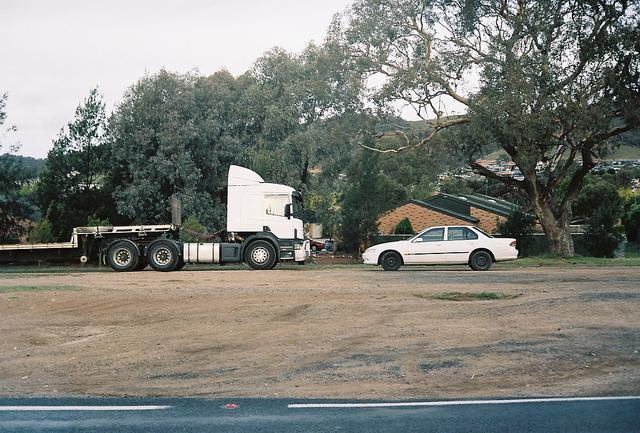What is this type of truck called?

Choices:
A) dump truck
B) cement truck
C) semi
D) pickup semi 